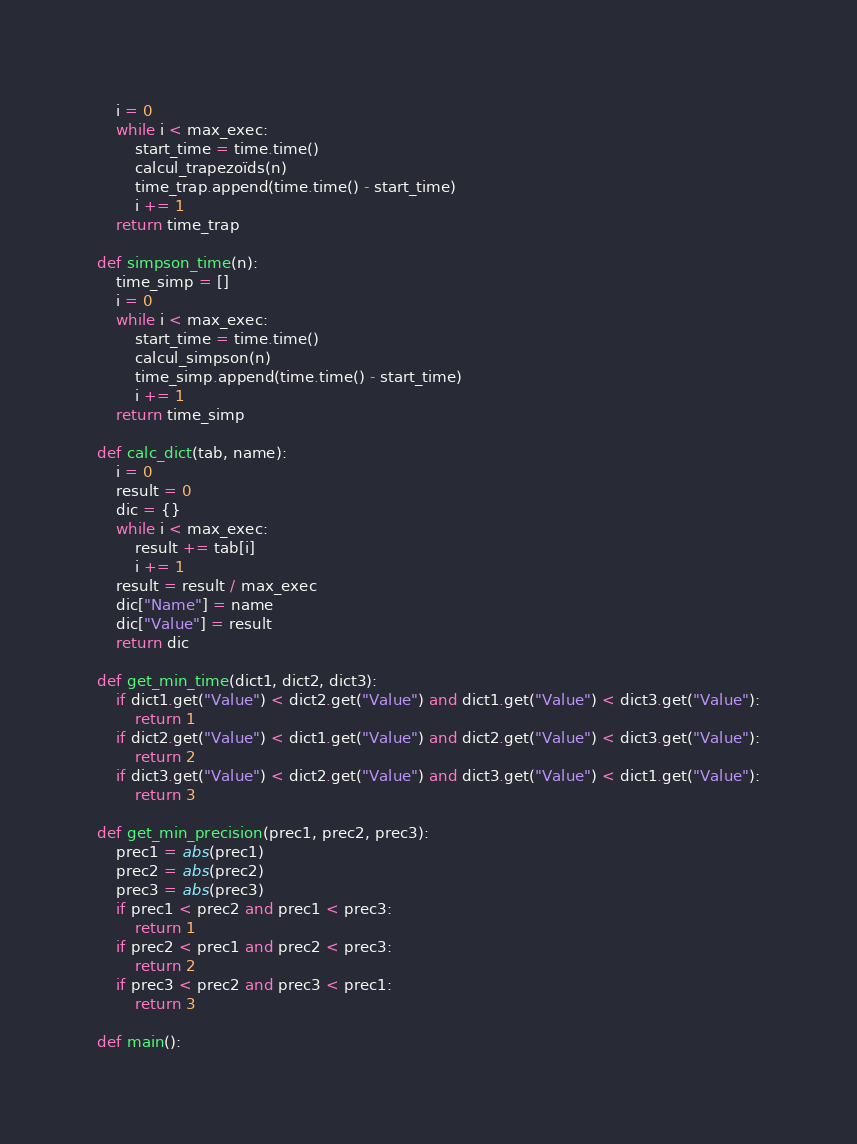<code> <loc_0><loc_0><loc_500><loc_500><_Python_>    i = 0
    while i < max_exec:
        start_time = time.time()
        calcul_trapezoïds(n)
        time_trap.append(time.time() - start_time)
        i += 1
    return time_trap

def simpson_time(n):
    time_simp = []
    i = 0
    while i < max_exec:
        start_time = time.time()
        calcul_simpson(n)
        time_simp.append(time.time() - start_time)
        i += 1
    return time_simp

def calc_dict(tab, name):
    i = 0
    result = 0
    dic = {}
    while i < max_exec:
        result += tab[i]
        i += 1
    result = result / max_exec
    dic["Name"] = name
    dic["Value"] = result
    return dic

def get_min_time(dict1, dict2, dict3):
    if dict1.get("Value") < dict2.get("Value") and dict1.get("Value") < dict3.get("Value"):
        return 1
    if dict2.get("Value") < dict1.get("Value") and dict2.get("Value") < dict3.get("Value"):
        return 2
    if dict3.get("Value") < dict2.get("Value") and dict3.get("Value") < dict1.get("Value"):
        return 3

def get_min_precision(prec1, prec2, prec3):
    prec1 = abs(prec1)
    prec2 = abs(prec2)
    prec3 = abs(prec3)
    if prec1 < prec2 and prec1 < prec3:
        return 1
    if prec2 < prec1 and prec2 < prec3:
        return 2
    if prec3 < prec2 and prec3 < prec1:
        return 3

def main():</code> 